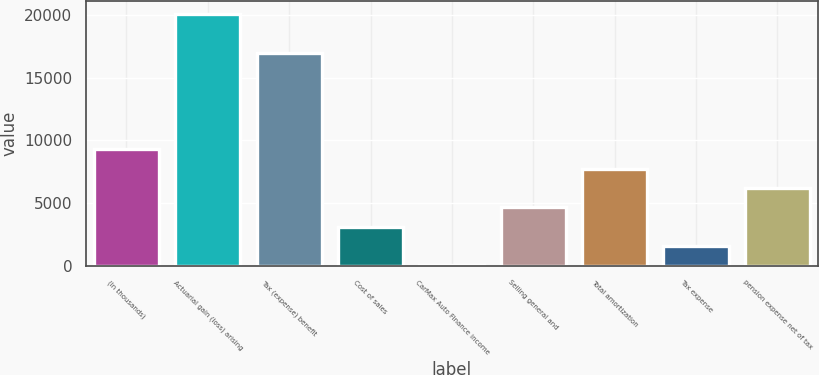<chart> <loc_0><loc_0><loc_500><loc_500><bar_chart><fcel>(In thousands)<fcel>Actuarial gain (loss) arising<fcel>Tax (expense) benefit<fcel>Cost of sales<fcel>CarMax Auto Finance income<fcel>Selling general and<fcel>Total amortization<fcel>Tax expense<fcel>pension expense net of tax<nl><fcel>9294.2<fcel>20093.1<fcel>17007.7<fcel>3123.4<fcel>38<fcel>4666.1<fcel>7751.5<fcel>1580.7<fcel>6208.8<nl></chart> 